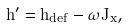<formula> <loc_0><loc_0><loc_500><loc_500>h ^ { \prime } = h _ { d e f } - \omega J _ { x } ,</formula> 